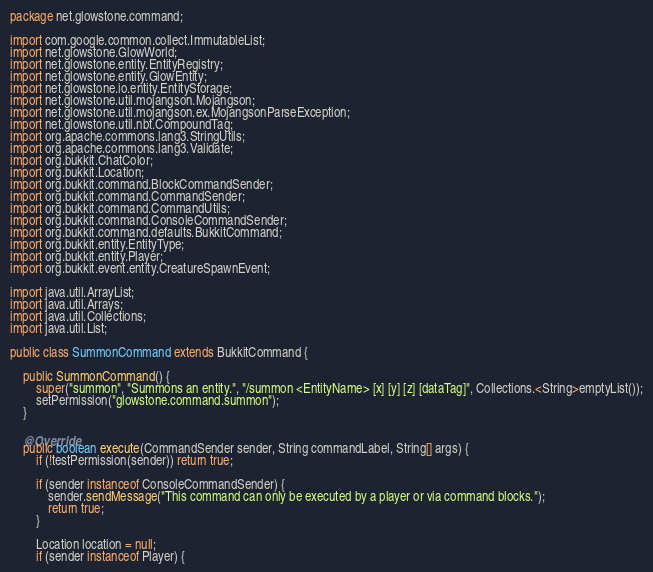Convert code to text. <code><loc_0><loc_0><loc_500><loc_500><_Java_>package net.glowstone.command;

import com.google.common.collect.ImmutableList;
import net.glowstone.GlowWorld;
import net.glowstone.entity.EntityRegistry;
import net.glowstone.entity.GlowEntity;
import net.glowstone.io.entity.EntityStorage;
import net.glowstone.util.mojangson.Mojangson;
import net.glowstone.util.mojangson.ex.MojangsonParseException;
import net.glowstone.util.nbt.CompoundTag;
import org.apache.commons.lang3.StringUtils;
import org.apache.commons.lang3.Validate;
import org.bukkit.ChatColor;
import org.bukkit.Location;
import org.bukkit.command.BlockCommandSender;
import org.bukkit.command.CommandSender;
import org.bukkit.command.CommandUtils;
import org.bukkit.command.ConsoleCommandSender;
import org.bukkit.command.defaults.BukkitCommand;
import org.bukkit.entity.EntityType;
import org.bukkit.entity.Player;
import org.bukkit.event.entity.CreatureSpawnEvent;

import java.util.ArrayList;
import java.util.Arrays;
import java.util.Collections;
import java.util.List;

public class SummonCommand extends BukkitCommand {

    public SummonCommand() {
        super("summon", "Summons an entity.", "/summon <EntityName> [x] [y] [z] [dataTag]", Collections.<String>emptyList());
        setPermission("glowstone.command.summon");
    }

    @Override
    public boolean execute(CommandSender sender, String commandLabel, String[] args) {
        if (!testPermission(sender)) return true;

        if (sender instanceof ConsoleCommandSender) {
            sender.sendMessage("This command can only be executed by a player or via command blocks.");
            return true;
        }

        Location location = null;
        if (sender instanceof Player) {</code> 